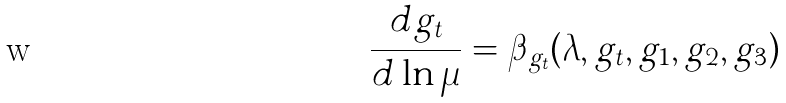<formula> <loc_0><loc_0><loc_500><loc_500>\frac { d g _ { t } } { d \ln \mu } = \beta _ { g _ { t } } ( \lambda , g _ { t } , g _ { 1 } , g _ { 2 } , g _ { 3 } )</formula> 